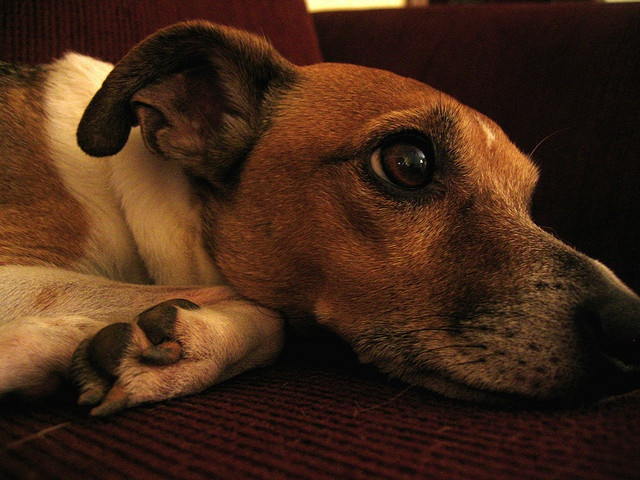Describe the objects in this image and their specific colors. I can see dog in black, maroon, and brown tones and couch in black, maroon, brown, and orange tones in this image. 